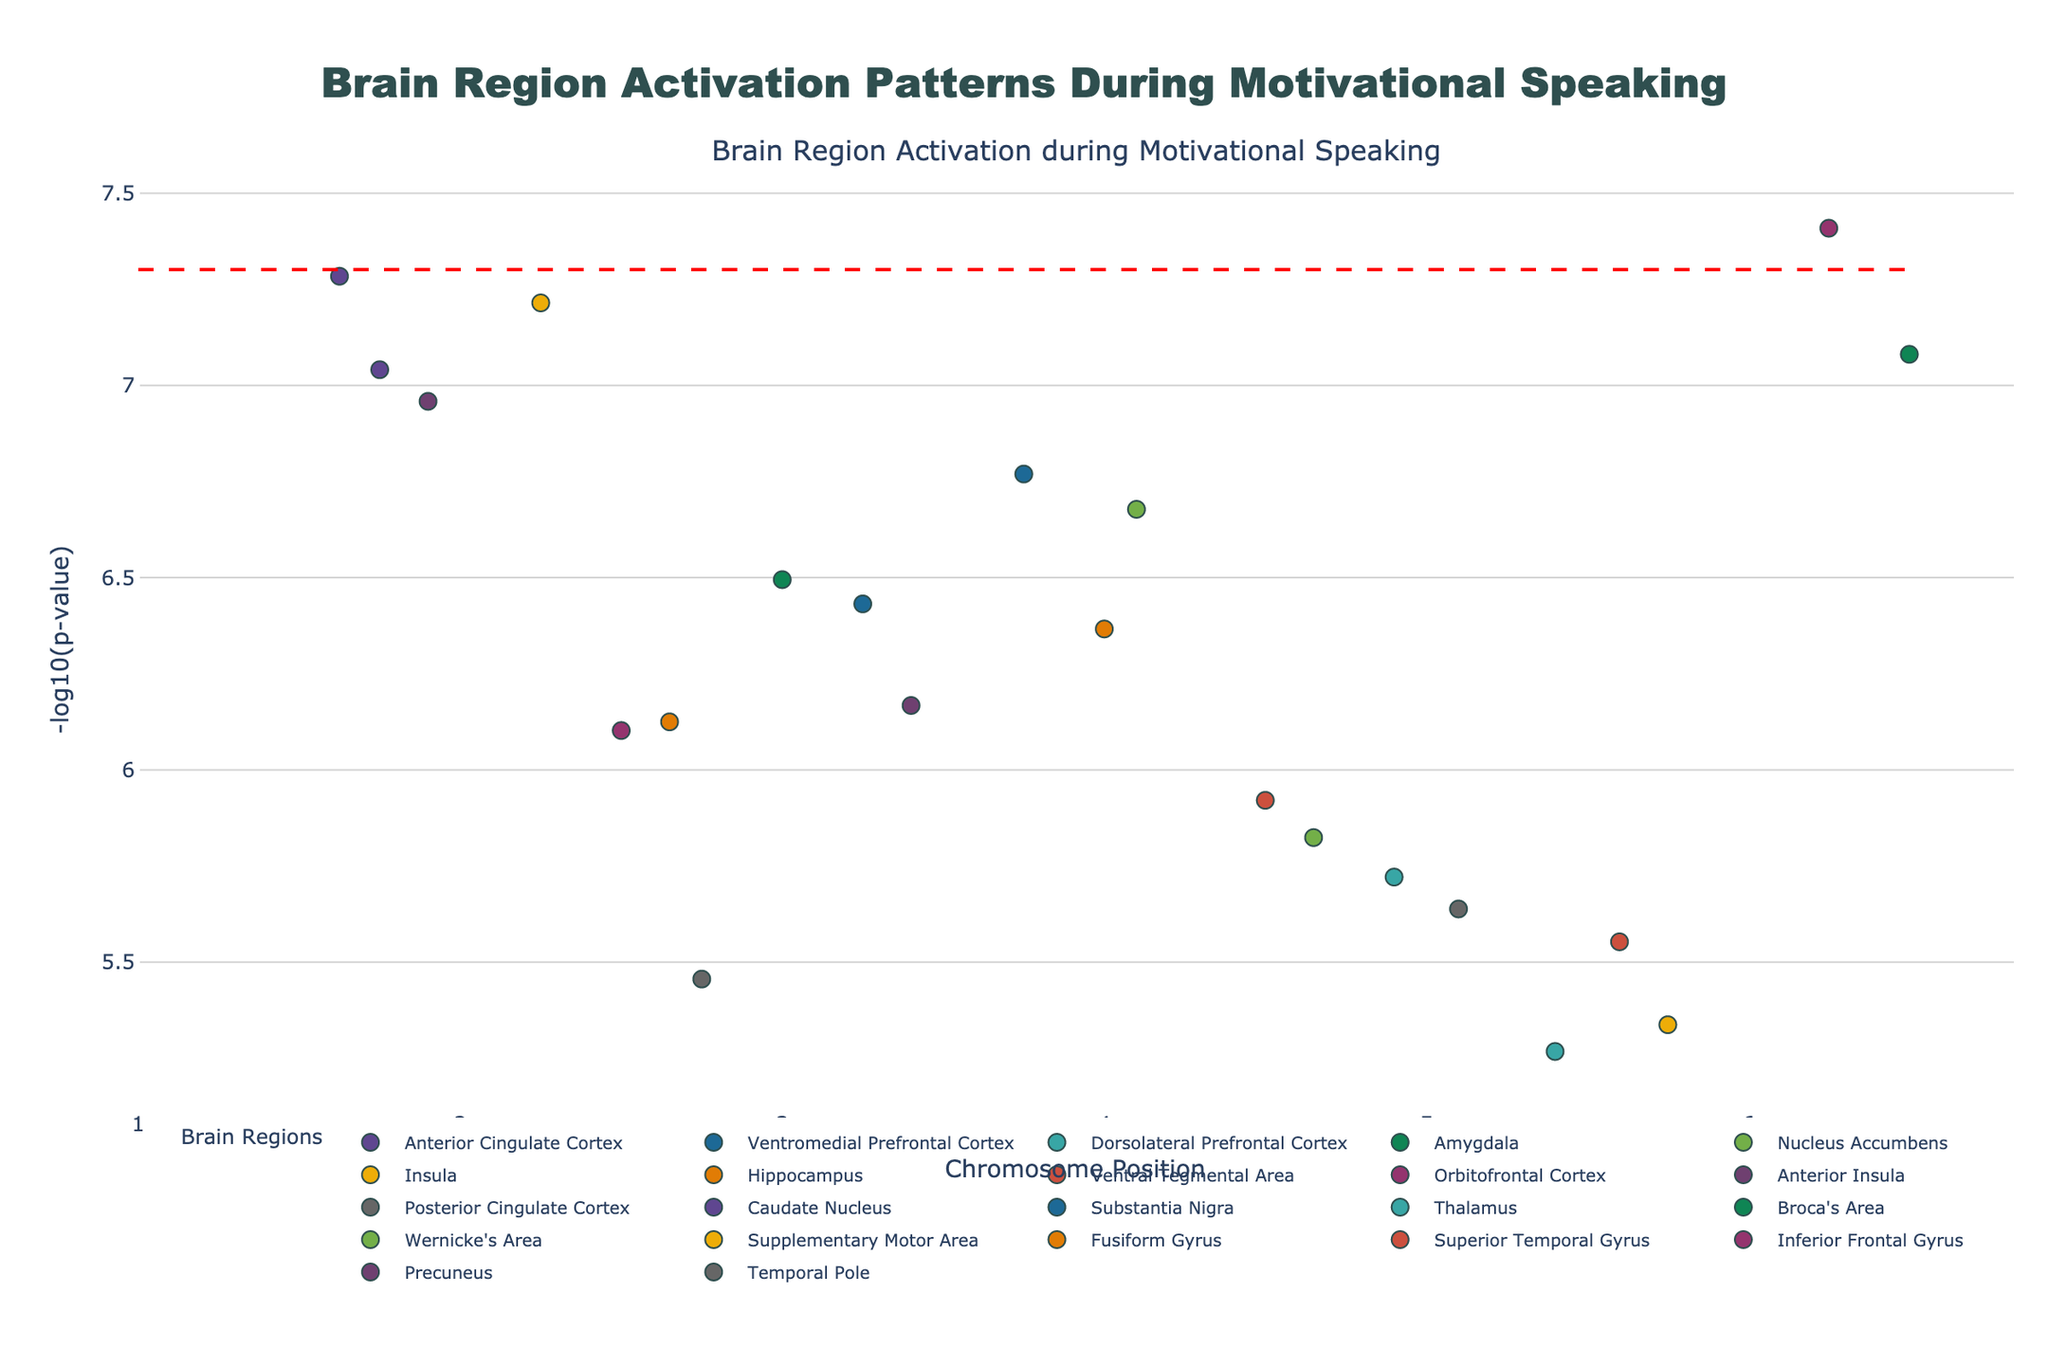What is the title of the figure? Look at the top of the plot where the title is displayed.
Answer: Brain Region Activation Patterns During Motivational Speaking What is the range of the x-axis, representing the chromosome positions? Check the x-axis labels and ticks to identify the range.
Answer: 0 to 110,000,000 Which brain region shows the activation with the smallest p-value? Identify the brain region with the highest -log10(p) value, as it corresponds to the smallest p-value.
Answer: Anterior Cingulate Cortex How many brain regions have activation patterns with a p-value less than 5e-8? Count the data points that are above the significance threshold line (-log10(5e-8)).
Answer: 3 What is the -log10(p-value) for the activation in the Broca's Area? Locate the position of Broca's Area on the plot and check its y-axis value.
Answer: Approximately 6.5 Which brain region has a higher -log10(p-value), Anterior Insula or Amygdala? Compare the heights of the data points corresponding to Anterior Insula and Amygdala on the y-axis.
Answer: Amygdala How far apart are the activation positions of the Ventromedial Prefrontal Cortex and Dorsolateral Prefrontal Cortex? Subtract the position value of the Dorsolateral Prefrontal Cortex from the position value of the Ventromedial Prefrontal Cortex.
Answer: 33,000,000 Which brain region is represented with the highest number of data points? Count and compare the number of points representing each brain region.
Answer: No specific region stands out with multiple points Which brain region corresponding to chromosome 12 shows significant activation? Identify the data point on chromosome 12 and check the associated brain region's name.
Answer: Caudate Nucleus Is there a brain region on chromosome 16 showing significant activation? Look at the plot for a data point on chromosome 16 and check if it exceeds the significance threshold.
Answer: Yes, Wernicke's Area 